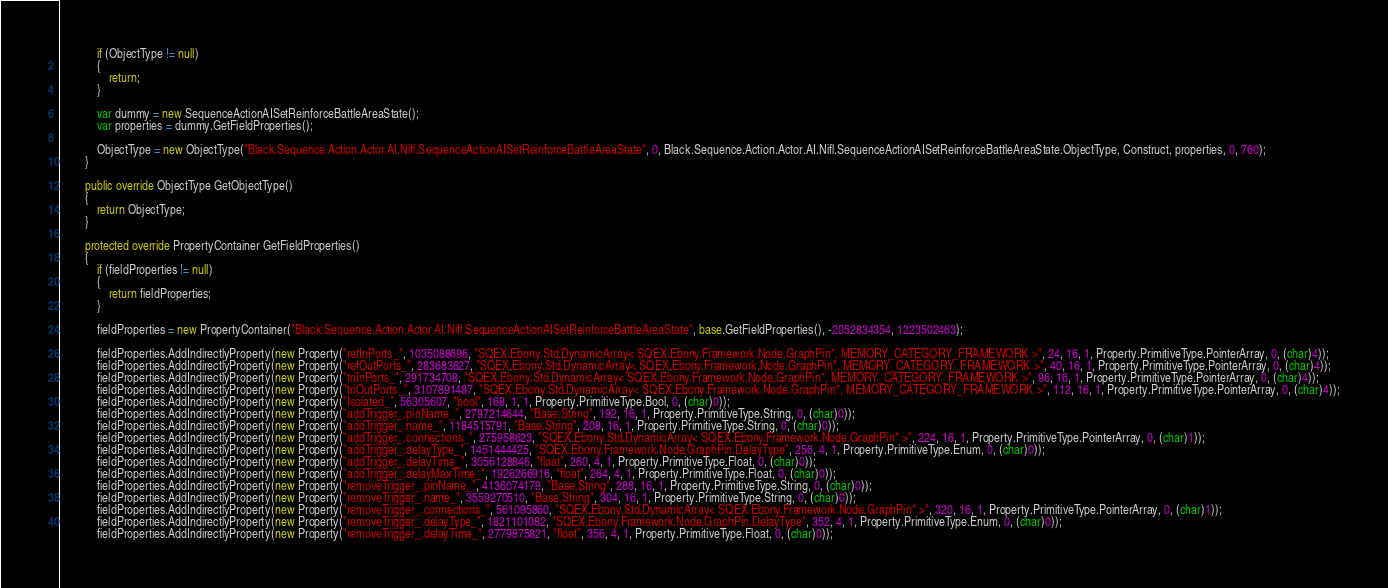<code> <loc_0><loc_0><loc_500><loc_500><_C#_>            if (ObjectType != null)
            {
                return;
            }

            var dummy = new SequenceActionAISetReinforceBattleAreaState();
            var properties = dummy.GetFieldProperties();

            ObjectType = new ObjectType("Black.Sequence.Action.Actor.AI.Nifl.SequenceActionAISetReinforceBattleAreaState", 0, Black.Sequence.Action.Actor.AI.Nifl.SequenceActionAISetReinforceBattleAreaState.ObjectType, Construct, properties, 0, 760);
        }
		
        public override ObjectType GetObjectType()
        {
            return ObjectType;
        }

        protected override PropertyContainer GetFieldProperties()
        {
            if (fieldProperties != null)
            {
                return fieldProperties;
            }

            fieldProperties = new PropertyContainer("Black.Sequence.Action.Actor.AI.Nifl.SequenceActionAISetReinforceBattleAreaState", base.GetFieldProperties(), -2052834354, 1223502463);
            
			fieldProperties.AddIndirectlyProperty(new Property("refInPorts_", 1035088696, "SQEX.Ebony.Std.DynamicArray< SQEX.Ebony.Framework.Node.GraphPin*, MEMORY_CATEGORY_FRAMEWORK >", 24, 16, 1, Property.PrimitiveType.PointerArray, 0, (char)4));
			fieldProperties.AddIndirectlyProperty(new Property("refOutPorts_", 283683627, "SQEX.Ebony.Std.DynamicArray< SQEX.Ebony.Framework.Node.GraphPin*, MEMORY_CATEGORY_FRAMEWORK >", 40, 16, 1, Property.PrimitiveType.PointerArray, 0, (char)4));
			fieldProperties.AddIndirectlyProperty(new Property("triInPorts_", 291734708, "SQEX.Ebony.Std.DynamicArray< SQEX.Ebony.Framework.Node.GraphPin*, MEMORY_CATEGORY_FRAMEWORK >", 96, 16, 1, Property.PrimitiveType.PointerArray, 0, (char)4));
			fieldProperties.AddIndirectlyProperty(new Property("triOutPorts_", 3107891487, "SQEX.Ebony.Std.DynamicArray< SQEX.Ebony.Framework.Node.GraphPin*, MEMORY_CATEGORY_FRAMEWORK >", 112, 16, 1, Property.PrimitiveType.PointerArray, 0, (char)4));
			fieldProperties.AddIndirectlyProperty(new Property("Isolated_", 56305607, "bool", 168, 1, 1, Property.PrimitiveType.Bool, 0, (char)0));
			fieldProperties.AddIndirectlyProperty(new Property("addTrigger_.pinName_", 2797214644, "Base.String", 192, 16, 1, Property.PrimitiveType.String, 0, (char)0));
			fieldProperties.AddIndirectlyProperty(new Property("addTrigger_.name_", 1184515791, "Base.String", 208, 16, 1, Property.PrimitiveType.String, 0, (char)0));
			fieldProperties.AddIndirectlyProperty(new Property("addTrigger_.connections_", 275958623, "SQEX.Ebony.Std.DynamicArray< SQEX.Ebony.Framework.Node.GraphPin* >", 224, 16, 1, Property.PrimitiveType.PointerArray, 0, (char)1));
			fieldProperties.AddIndirectlyProperty(new Property("addTrigger_.delayType_", 1451444425, "SQEX.Ebony.Framework.Node.GraphPin.DelayType", 256, 4, 1, Property.PrimitiveType.Enum, 0, (char)0));
			fieldProperties.AddIndirectlyProperty(new Property("addTrigger_.delayTime_", 3056128846, "float", 260, 4, 1, Property.PrimitiveType.Float, 0, (char)0));
			fieldProperties.AddIndirectlyProperty(new Property("addTrigger_.delayMaxTime_", 1926266916, "float", 264, 4, 1, Property.PrimitiveType.Float, 0, (char)0));
			fieldProperties.AddIndirectlyProperty(new Property("removeTrigger_.pinName_", 4136074179, "Base.String", 288, 16, 1, Property.PrimitiveType.String, 0, (char)0));
			fieldProperties.AddIndirectlyProperty(new Property("removeTrigger_.name_", 3559270510, "Base.String", 304, 16, 1, Property.PrimitiveType.String, 0, (char)0));
			fieldProperties.AddIndirectlyProperty(new Property("removeTrigger_.connections_", 561095860, "SQEX.Ebony.Std.DynamicArray< SQEX.Ebony.Framework.Node.GraphPin* >", 320, 16, 1, Property.PrimitiveType.PointerArray, 0, (char)1));
			fieldProperties.AddIndirectlyProperty(new Property("removeTrigger_.delayType_", 1821101082, "SQEX.Ebony.Framework.Node.GraphPin.DelayType", 352, 4, 1, Property.PrimitiveType.Enum, 0, (char)0));
			fieldProperties.AddIndirectlyProperty(new Property("removeTrigger_.delayTime_", 2779875821, "float", 356, 4, 1, Property.PrimitiveType.Float, 0, (char)0));</code> 